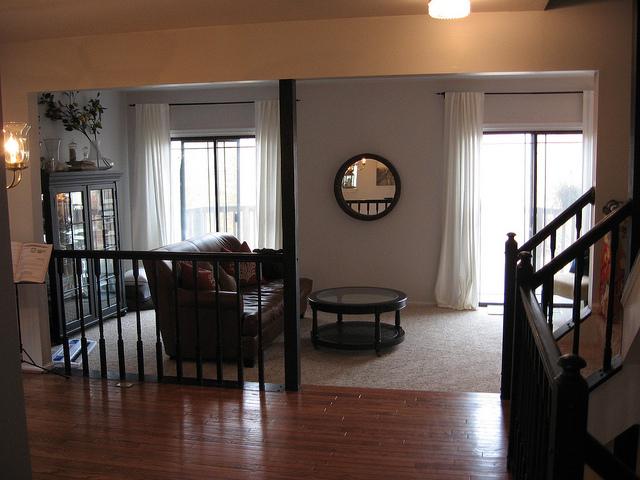Is the front part of the room carpeted?
Be succinct. Yes. What is the object in between the windows on the wall?
Be succinct. Mirror. What material makes up the coffee table top?
Short answer required. Glass. 